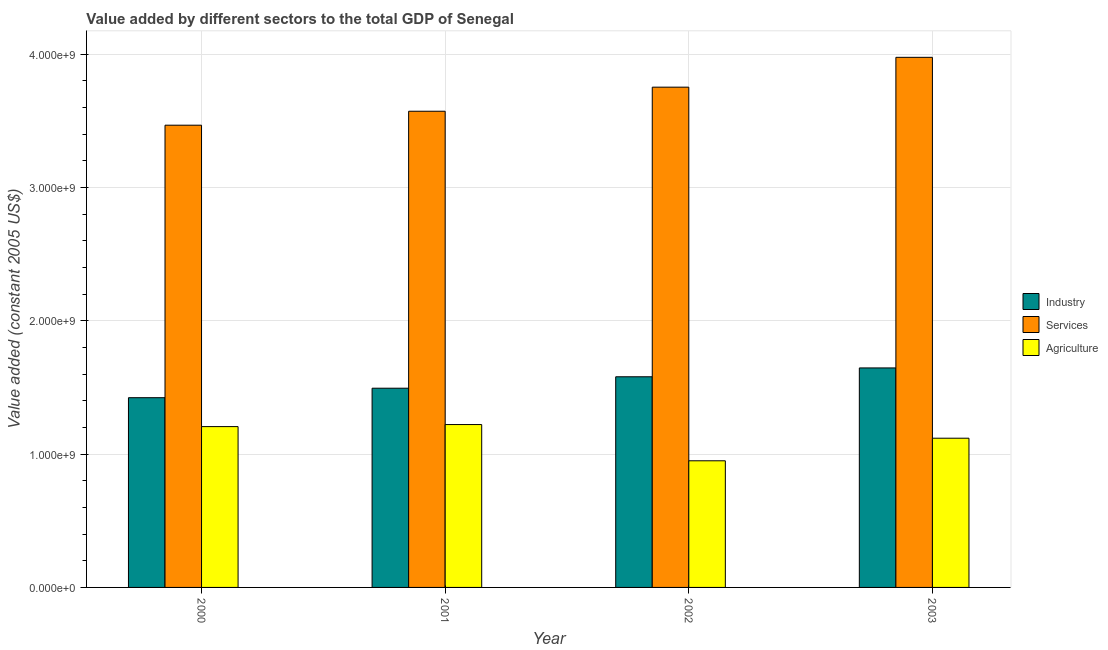Are the number of bars on each tick of the X-axis equal?
Your answer should be very brief. Yes. What is the label of the 2nd group of bars from the left?
Make the answer very short. 2001. What is the value added by agricultural sector in 2003?
Offer a very short reply. 1.12e+09. Across all years, what is the maximum value added by services?
Your answer should be very brief. 3.98e+09. Across all years, what is the minimum value added by agricultural sector?
Make the answer very short. 9.50e+08. In which year was the value added by agricultural sector maximum?
Provide a short and direct response. 2001. What is the total value added by services in the graph?
Give a very brief answer. 1.48e+1. What is the difference between the value added by industrial sector in 2000 and that in 2002?
Offer a terse response. -1.57e+08. What is the difference between the value added by services in 2003 and the value added by agricultural sector in 2001?
Keep it short and to the point. 4.04e+08. What is the average value added by services per year?
Provide a succinct answer. 3.69e+09. In the year 2001, what is the difference between the value added by services and value added by agricultural sector?
Offer a very short reply. 0. In how many years, is the value added by agricultural sector greater than 2000000000 US$?
Provide a short and direct response. 0. What is the ratio of the value added by industrial sector in 2001 to that in 2003?
Provide a short and direct response. 0.91. What is the difference between the highest and the second highest value added by industrial sector?
Your answer should be compact. 6.64e+07. What is the difference between the highest and the lowest value added by industrial sector?
Ensure brevity in your answer.  2.23e+08. In how many years, is the value added by industrial sector greater than the average value added by industrial sector taken over all years?
Offer a terse response. 2. Is the sum of the value added by industrial sector in 2001 and 2002 greater than the maximum value added by services across all years?
Your response must be concise. Yes. What does the 1st bar from the left in 2000 represents?
Your answer should be compact. Industry. What does the 3rd bar from the right in 2001 represents?
Make the answer very short. Industry. How many years are there in the graph?
Your response must be concise. 4. Does the graph contain any zero values?
Provide a short and direct response. No. Where does the legend appear in the graph?
Your answer should be very brief. Center right. How are the legend labels stacked?
Your response must be concise. Vertical. What is the title of the graph?
Offer a very short reply. Value added by different sectors to the total GDP of Senegal. Does "Secondary" appear as one of the legend labels in the graph?
Offer a very short reply. No. What is the label or title of the Y-axis?
Offer a terse response. Value added (constant 2005 US$). What is the Value added (constant 2005 US$) in Industry in 2000?
Offer a terse response. 1.42e+09. What is the Value added (constant 2005 US$) in Services in 2000?
Offer a terse response. 3.47e+09. What is the Value added (constant 2005 US$) of Agriculture in 2000?
Your response must be concise. 1.21e+09. What is the Value added (constant 2005 US$) of Industry in 2001?
Ensure brevity in your answer.  1.49e+09. What is the Value added (constant 2005 US$) of Services in 2001?
Your answer should be compact. 3.57e+09. What is the Value added (constant 2005 US$) in Agriculture in 2001?
Your response must be concise. 1.22e+09. What is the Value added (constant 2005 US$) in Industry in 2002?
Keep it short and to the point. 1.58e+09. What is the Value added (constant 2005 US$) in Services in 2002?
Ensure brevity in your answer.  3.75e+09. What is the Value added (constant 2005 US$) in Agriculture in 2002?
Make the answer very short. 9.50e+08. What is the Value added (constant 2005 US$) in Industry in 2003?
Give a very brief answer. 1.65e+09. What is the Value added (constant 2005 US$) of Services in 2003?
Keep it short and to the point. 3.98e+09. What is the Value added (constant 2005 US$) of Agriculture in 2003?
Your answer should be very brief. 1.12e+09. Across all years, what is the maximum Value added (constant 2005 US$) of Industry?
Ensure brevity in your answer.  1.65e+09. Across all years, what is the maximum Value added (constant 2005 US$) of Services?
Your response must be concise. 3.98e+09. Across all years, what is the maximum Value added (constant 2005 US$) of Agriculture?
Offer a terse response. 1.22e+09. Across all years, what is the minimum Value added (constant 2005 US$) in Industry?
Your answer should be compact. 1.42e+09. Across all years, what is the minimum Value added (constant 2005 US$) in Services?
Your answer should be compact. 3.47e+09. Across all years, what is the minimum Value added (constant 2005 US$) in Agriculture?
Keep it short and to the point. 9.50e+08. What is the total Value added (constant 2005 US$) in Industry in the graph?
Your response must be concise. 6.14e+09. What is the total Value added (constant 2005 US$) in Services in the graph?
Your response must be concise. 1.48e+1. What is the total Value added (constant 2005 US$) in Agriculture in the graph?
Offer a very short reply. 4.50e+09. What is the difference between the Value added (constant 2005 US$) of Industry in 2000 and that in 2001?
Your answer should be compact. -7.12e+07. What is the difference between the Value added (constant 2005 US$) in Services in 2000 and that in 2001?
Your answer should be compact. -1.05e+08. What is the difference between the Value added (constant 2005 US$) of Agriculture in 2000 and that in 2001?
Your answer should be very brief. -1.54e+07. What is the difference between the Value added (constant 2005 US$) in Industry in 2000 and that in 2002?
Make the answer very short. -1.57e+08. What is the difference between the Value added (constant 2005 US$) of Services in 2000 and that in 2002?
Offer a terse response. -2.85e+08. What is the difference between the Value added (constant 2005 US$) of Agriculture in 2000 and that in 2002?
Your response must be concise. 2.56e+08. What is the difference between the Value added (constant 2005 US$) in Industry in 2000 and that in 2003?
Give a very brief answer. -2.23e+08. What is the difference between the Value added (constant 2005 US$) of Services in 2000 and that in 2003?
Your answer should be compact. -5.09e+08. What is the difference between the Value added (constant 2005 US$) in Agriculture in 2000 and that in 2003?
Offer a very short reply. 8.71e+07. What is the difference between the Value added (constant 2005 US$) in Industry in 2001 and that in 2002?
Your answer should be compact. -8.58e+07. What is the difference between the Value added (constant 2005 US$) in Services in 2001 and that in 2002?
Keep it short and to the point. -1.81e+08. What is the difference between the Value added (constant 2005 US$) of Agriculture in 2001 and that in 2002?
Ensure brevity in your answer.  2.72e+08. What is the difference between the Value added (constant 2005 US$) in Industry in 2001 and that in 2003?
Your answer should be very brief. -1.52e+08. What is the difference between the Value added (constant 2005 US$) of Services in 2001 and that in 2003?
Your response must be concise. -4.04e+08. What is the difference between the Value added (constant 2005 US$) of Agriculture in 2001 and that in 2003?
Offer a very short reply. 1.02e+08. What is the difference between the Value added (constant 2005 US$) of Industry in 2002 and that in 2003?
Your answer should be compact. -6.64e+07. What is the difference between the Value added (constant 2005 US$) in Services in 2002 and that in 2003?
Ensure brevity in your answer.  -2.24e+08. What is the difference between the Value added (constant 2005 US$) of Agriculture in 2002 and that in 2003?
Offer a very short reply. -1.69e+08. What is the difference between the Value added (constant 2005 US$) in Industry in 2000 and the Value added (constant 2005 US$) in Services in 2001?
Offer a terse response. -2.15e+09. What is the difference between the Value added (constant 2005 US$) of Industry in 2000 and the Value added (constant 2005 US$) of Agriculture in 2001?
Your answer should be compact. 2.01e+08. What is the difference between the Value added (constant 2005 US$) of Services in 2000 and the Value added (constant 2005 US$) of Agriculture in 2001?
Provide a succinct answer. 2.25e+09. What is the difference between the Value added (constant 2005 US$) in Industry in 2000 and the Value added (constant 2005 US$) in Services in 2002?
Keep it short and to the point. -2.33e+09. What is the difference between the Value added (constant 2005 US$) of Industry in 2000 and the Value added (constant 2005 US$) of Agriculture in 2002?
Provide a short and direct response. 4.73e+08. What is the difference between the Value added (constant 2005 US$) of Services in 2000 and the Value added (constant 2005 US$) of Agriculture in 2002?
Provide a short and direct response. 2.52e+09. What is the difference between the Value added (constant 2005 US$) in Industry in 2000 and the Value added (constant 2005 US$) in Services in 2003?
Offer a terse response. -2.55e+09. What is the difference between the Value added (constant 2005 US$) of Industry in 2000 and the Value added (constant 2005 US$) of Agriculture in 2003?
Provide a succinct answer. 3.04e+08. What is the difference between the Value added (constant 2005 US$) in Services in 2000 and the Value added (constant 2005 US$) in Agriculture in 2003?
Ensure brevity in your answer.  2.35e+09. What is the difference between the Value added (constant 2005 US$) of Industry in 2001 and the Value added (constant 2005 US$) of Services in 2002?
Provide a short and direct response. -2.26e+09. What is the difference between the Value added (constant 2005 US$) in Industry in 2001 and the Value added (constant 2005 US$) in Agriculture in 2002?
Keep it short and to the point. 5.44e+08. What is the difference between the Value added (constant 2005 US$) of Services in 2001 and the Value added (constant 2005 US$) of Agriculture in 2002?
Your answer should be very brief. 2.62e+09. What is the difference between the Value added (constant 2005 US$) in Industry in 2001 and the Value added (constant 2005 US$) in Services in 2003?
Your answer should be very brief. -2.48e+09. What is the difference between the Value added (constant 2005 US$) in Industry in 2001 and the Value added (constant 2005 US$) in Agriculture in 2003?
Offer a very short reply. 3.75e+08. What is the difference between the Value added (constant 2005 US$) of Services in 2001 and the Value added (constant 2005 US$) of Agriculture in 2003?
Your answer should be very brief. 2.45e+09. What is the difference between the Value added (constant 2005 US$) in Industry in 2002 and the Value added (constant 2005 US$) in Services in 2003?
Your response must be concise. -2.40e+09. What is the difference between the Value added (constant 2005 US$) in Industry in 2002 and the Value added (constant 2005 US$) in Agriculture in 2003?
Provide a short and direct response. 4.61e+08. What is the difference between the Value added (constant 2005 US$) in Services in 2002 and the Value added (constant 2005 US$) in Agriculture in 2003?
Your answer should be compact. 2.63e+09. What is the average Value added (constant 2005 US$) of Industry per year?
Offer a very short reply. 1.54e+09. What is the average Value added (constant 2005 US$) of Services per year?
Keep it short and to the point. 3.69e+09. What is the average Value added (constant 2005 US$) of Agriculture per year?
Your response must be concise. 1.12e+09. In the year 2000, what is the difference between the Value added (constant 2005 US$) of Industry and Value added (constant 2005 US$) of Services?
Your answer should be very brief. -2.04e+09. In the year 2000, what is the difference between the Value added (constant 2005 US$) in Industry and Value added (constant 2005 US$) in Agriculture?
Give a very brief answer. 2.17e+08. In the year 2000, what is the difference between the Value added (constant 2005 US$) of Services and Value added (constant 2005 US$) of Agriculture?
Your answer should be compact. 2.26e+09. In the year 2001, what is the difference between the Value added (constant 2005 US$) in Industry and Value added (constant 2005 US$) in Services?
Provide a succinct answer. -2.08e+09. In the year 2001, what is the difference between the Value added (constant 2005 US$) of Industry and Value added (constant 2005 US$) of Agriculture?
Your answer should be compact. 2.73e+08. In the year 2001, what is the difference between the Value added (constant 2005 US$) in Services and Value added (constant 2005 US$) in Agriculture?
Offer a terse response. 2.35e+09. In the year 2002, what is the difference between the Value added (constant 2005 US$) of Industry and Value added (constant 2005 US$) of Services?
Give a very brief answer. -2.17e+09. In the year 2002, what is the difference between the Value added (constant 2005 US$) in Industry and Value added (constant 2005 US$) in Agriculture?
Provide a succinct answer. 6.30e+08. In the year 2002, what is the difference between the Value added (constant 2005 US$) in Services and Value added (constant 2005 US$) in Agriculture?
Provide a short and direct response. 2.80e+09. In the year 2003, what is the difference between the Value added (constant 2005 US$) in Industry and Value added (constant 2005 US$) in Services?
Offer a very short reply. -2.33e+09. In the year 2003, what is the difference between the Value added (constant 2005 US$) of Industry and Value added (constant 2005 US$) of Agriculture?
Give a very brief answer. 5.27e+08. In the year 2003, what is the difference between the Value added (constant 2005 US$) in Services and Value added (constant 2005 US$) in Agriculture?
Ensure brevity in your answer.  2.86e+09. What is the ratio of the Value added (constant 2005 US$) in Services in 2000 to that in 2001?
Offer a very short reply. 0.97. What is the ratio of the Value added (constant 2005 US$) in Agriculture in 2000 to that in 2001?
Keep it short and to the point. 0.99. What is the ratio of the Value added (constant 2005 US$) in Industry in 2000 to that in 2002?
Keep it short and to the point. 0.9. What is the ratio of the Value added (constant 2005 US$) of Services in 2000 to that in 2002?
Provide a short and direct response. 0.92. What is the ratio of the Value added (constant 2005 US$) in Agriculture in 2000 to that in 2002?
Ensure brevity in your answer.  1.27. What is the ratio of the Value added (constant 2005 US$) in Industry in 2000 to that in 2003?
Your response must be concise. 0.86. What is the ratio of the Value added (constant 2005 US$) in Services in 2000 to that in 2003?
Your response must be concise. 0.87. What is the ratio of the Value added (constant 2005 US$) of Agriculture in 2000 to that in 2003?
Give a very brief answer. 1.08. What is the ratio of the Value added (constant 2005 US$) of Industry in 2001 to that in 2002?
Ensure brevity in your answer.  0.95. What is the ratio of the Value added (constant 2005 US$) in Services in 2001 to that in 2002?
Offer a very short reply. 0.95. What is the ratio of the Value added (constant 2005 US$) in Agriculture in 2001 to that in 2002?
Ensure brevity in your answer.  1.29. What is the ratio of the Value added (constant 2005 US$) in Industry in 2001 to that in 2003?
Your answer should be very brief. 0.91. What is the ratio of the Value added (constant 2005 US$) in Services in 2001 to that in 2003?
Provide a short and direct response. 0.9. What is the ratio of the Value added (constant 2005 US$) of Agriculture in 2001 to that in 2003?
Ensure brevity in your answer.  1.09. What is the ratio of the Value added (constant 2005 US$) in Industry in 2002 to that in 2003?
Give a very brief answer. 0.96. What is the ratio of the Value added (constant 2005 US$) of Services in 2002 to that in 2003?
Provide a succinct answer. 0.94. What is the ratio of the Value added (constant 2005 US$) in Agriculture in 2002 to that in 2003?
Your response must be concise. 0.85. What is the difference between the highest and the second highest Value added (constant 2005 US$) in Industry?
Offer a very short reply. 6.64e+07. What is the difference between the highest and the second highest Value added (constant 2005 US$) in Services?
Your response must be concise. 2.24e+08. What is the difference between the highest and the second highest Value added (constant 2005 US$) in Agriculture?
Give a very brief answer. 1.54e+07. What is the difference between the highest and the lowest Value added (constant 2005 US$) of Industry?
Ensure brevity in your answer.  2.23e+08. What is the difference between the highest and the lowest Value added (constant 2005 US$) of Services?
Your response must be concise. 5.09e+08. What is the difference between the highest and the lowest Value added (constant 2005 US$) of Agriculture?
Offer a terse response. 2.72e+08. 